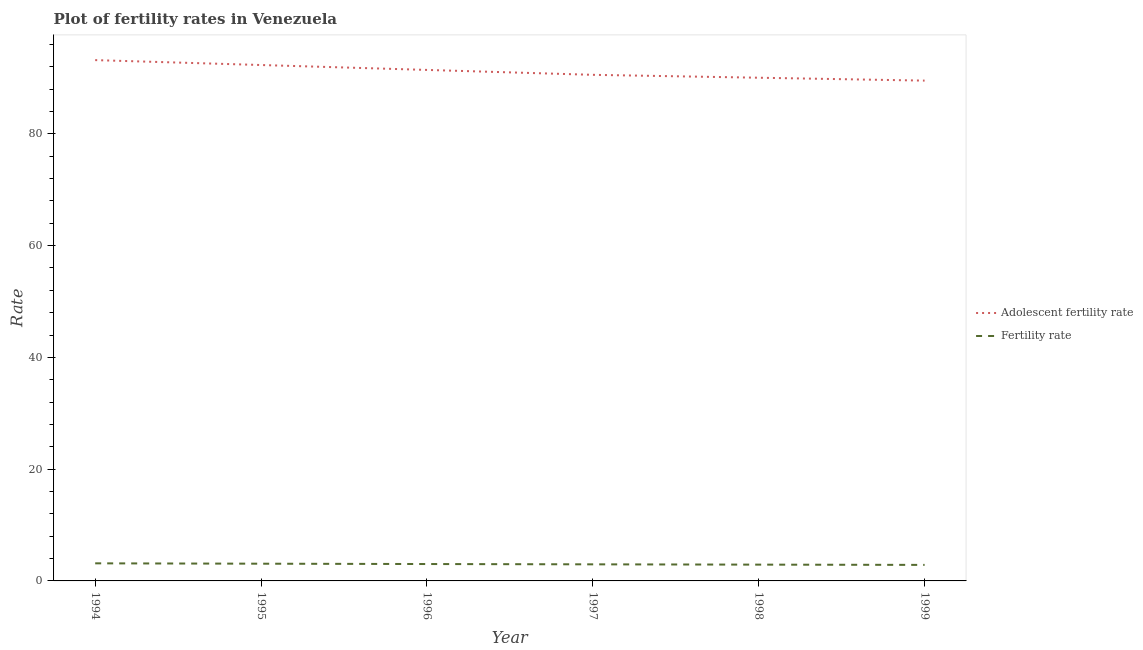How many different coloured lines are there?
Make the answer very short. 2. Does the line corresponding to fertility rate intersect with the line corresponding to adolescent fertility rate?
Give a very brief answer. No. Is the number of lines equal to the number of legend labels?
Offer a terse response. Yes. What is the fertility rate in 1996?
Offer a terse response. 3.02. Across all years, what is the maximum adolescent fertility rate?
Your answer should be very brief. 93.18. Across all years, what is the minimum adolescent fertility rate?
Keep it short and to the point. 89.52. In which year was the adolescent fertility rate maximum?
Keep it short and to the point. 1994. In which year was the adolescent fertility rate minimum?
Ensure brevity in your answer.  1999. What is the total adolescent fertility rate in the graph?
Provide a succinct answer. 547.02. What is the difference between the fertility rate in 1998 and that in 1999?
Keep it short and to the point. 0.05. What is the difference between the adolescent fertility rate in 1998 and the fertility rate in 1996?
Your answer should be compact. 87.01. What is the average adolescent fertility rate per year?
Keep it short and to the point. 91.17. In the year 1998, what is the difference between the fertility rate and adolescent fertility rate?
Make the answer very short. -87.12. What is the ratio of the fertility rate in 1994 to that in 1998?
Give a very brief answer. 1.08. Is the difference between the adolescent fertility rate in 1997 and 1998 greater than the difference between the fertility rate in 1997 and 1998?
Ensure brevity in your answer.  Yes. What is the difference between the highest and the second highest fertility rate?
Make the answer very short. 0.06. What is the difference between the highest and the lowest adolescent fertility rate?
Keep it short and to the point. 3.67. In how many years, is the fertility rate greater than the average fertility rate taken over all years?
Give a very brief answer. 3. Is the sum of the adolescent fertility rate in 1996 and 1999 greater than the maximum fertility rate across all years?
Your answer should be very brief. Yes. Does the adolescent fertility rate monotonically increase over the years?
Give a very brief answer. No. Is the fertility rate strictly less than the adolescent fertility rate over the years?
Give a very brief answer. Yes. How many years are there in the graph?
Keep it short and to the point. 6. Are the values on the major ticks of Y-axis written in scientific E-notation?
Give a very brief answer. No. Does the graph contain any zero values?
Offer a terse response. No. Does the graph contain grids?
Provide a succinct answer. No. Where does the legend appear in the graph?
Offer a very short reply. Center right. How are the legend labels stacked?
Provide a succinct answer. Vertical. What is the title of the graph?
Ensure brevity in your answer.  Plot of fertility rates in Venezuela. What is the label or title of the Y-axis?
Provide a succinct answer. Rate. What is the Rate in Adolescent fertility rate in 1994?
Your response must be concise. 93.18. What is the Rate in Fertility rate in 1994?
Give a very brief answer. 3.15. What is the Rate of Adolescent fertility rate in 1995?
Provide a succinct answer. 92.31. What is the Rate in Fertility rate in 1995?
Provide a succinct answer. 3.08. What is the Rate in Adolescent fertility rate in 1996?
Your response must be concise. 91.43. What is the Rate of Fertility rate in 1996?
Make the answer very short. 3.02. What is the Rate in Adolescent fertility rate in 1997?
Give a very brief answer. 90.55. What is the Rate of Fertility rate in 1997?
Ensure brevity in your answer.  2.97. What is the Rate of Adolescent fertility rate in 1998?
Provide a succinct answer. 90.03. What is the Rate of Fertility rate in 1998?
Keep it short and to the point. 2.92. What is the Rate of Adolescent fertility rate in 1999?
Your answer should be compact. 89.52. What is the Rate in Fertility rate in 1999?
Keep it short and to the point. 2.87. Across all years, what is the maximum Rate of Adolescent fertility rate?
Your answer should be very brief. 93.18. Across all years, what is the maximum Rate in Fertility rate?
Your answer should be very brief. 3.15. Across all years, what is the minimum Rate in Adolescent fertility rate?
Keep it short and to the point. 89.52. Across all years, what is the minimum Rate of Fertility rate?
Ensure brevity in your answer.  2.87. What is the total Rate of Adolescent fertility rate in the graph?
Your response must be concise. 547.02. What is the difference between the Rate of Adolescent fertility rate in 1994 and that in 1995?
Keep it short and to the point. 0.88. What is the difference between the Rate of Fertility rate in 1994 and that in 1995?
Give a very brief answer. 0.07. What is the difference between the Rate of Adolescent fertility rate in 1994 and that in 1996?
Provide a short and direct response. 1.76. What is the difference between the Rate of Adolescent fertility rate in 1994 and that in 1997?
Your response must be concise. 2.63. What is the difference between the Rate of Fertility rate in 1994 and that in 1997?
Make the answer very short. 0.18. What is the difference between the Rate in Adolescent fertility rate in 1994 and that in 1998?
Provide a short and direct response. 3.15. What is the difference between the Rate in Fertility rate in 1994 and that in 1998?
Offer a terse response. 0.23. What is the difference between the Rate of Adolescent fertility rate in 1994 and that in 1999?
Provide a short and direct response. 3.67. What is the difference between the Rate in Fertility rate in 1994 and that in 1999?
Give a very brief answer. 0.28. What is the difference between the Rate of Adolescent fertility rate in 1995 and that in 1996?
Offer a terse response. 0.88. What is the difference between the Rate in Fertility rate in 1995 and that in 1996?
Make the answer very short. 0.06. What is the difference between the Rate of Adolescent fertility rate in 1995 and that in 1997?
Offer a very short reply. 1.76. What is the difference between the Rate of Fertility rate in 1995 and that in 1997?
Offer a very short reply. 0.12. What is the difference between the Rate of Adolescent fertility rate in 1995 and that in 1998?
Your answer should be compact. 2.27. What is the difference between the Rate in Fertility rate in 1995 and that in 1998?
Provide a succinct answer. 0.17. What is the difference between the Rate in Adolescent fertility rate in 1995 and that in 1999?
Provide a short and direct response. 2.79. What is the difference between the Rate of Fertility rate in 1995 and that in 1999?
Keep it short and to the point. 0.21. What is the difference between the Rate of Adolescent fertility rate in 1996 and that in 1997?
Keep it short and to the point. 0.88. What is the difference between the Rate in Fertility rate in 1996 and that in 1997?
Offer a terse response. 0.06. What is the difference between the Rate of Adolescent fertility rate in 1996 and that in 1998?
Keep it short and to the point. 1.4. What is the difference between the Rate in Fertility rate in 1996 and that in 1998?
Your answer should be compact. 0.11. What is the difference between the Rate of Adolescent fertility rate in 1996 and that in 1999?
Your answer should be compact. 1.91. What is the difference between the Rate in Fertility rate in 1996 and that in 1999?
Offer a terse response. 0.15. What is the difference between the Rate of Adolescent fertility rate in 1997 and that in 1998?
Offer a very short reply. 0.52. What is the difference between the Rate of Fertility rate in 1997 and that in 1998?
Give a very brief answer. 0.05. What is the difference between the Rate in Adolescent fertility rate in 1997 and that in 1999?
Offer a terse response. 1.04. What is the difference between the Rate of Fertility rate in 1997 and that in 1999?
Your response must be concise. 0.1. What is the difference between the Rate in Adolescent fertility rate in 1998 and that in 1999?
Your answer should be compact. 0.52. What is the difference between the Rate of Fertility rate in 1998 and that in 1999?
Your answer should be very brief. 0.05. What is the difference between the Rate of Adolescent fertility rate in 1994 and the Rate of Fertility rate in 1995?
Keep it short and to the point. 90.1. What is the difference between the Rate in Adolescent fertility rate in 1994 and the Rate in Fertility rate in 1996?
Provide a succinct answer. 90.16. What is the difference between the Rate in Adolescent fertility rate in 1994 and the Rate in Fertility rate in 1997?
Offer a very short reply. 90.22. What is the difference between the Rate of Adolescent fertility rate in 1994 and the Rate of Fertility rate in 1998?
Your response must be concise. 90.27. What is the difference between the Rate of Adolescent fertility rate in 1994 and the Rate of Fertility rate in 1999?
Make the answer very short. 90.32. What is the difference between the Rate of Adolescent fertility rate in 1995 and the Rate of Fertility rate in 1996?
Your answer should be very brief. 89.28. What is the difference between the Rate in Adolescent fertility rate in 1995 and the Rate in Fertility rate in 1997?
Keep it short and to the point. 89.34. What is the difference between the Rate in Adolescent fertility rate in 1995 and the Rate in Fertility rate in 1998?
Keep it short and to the point. 89.39. What is the difference between the Rate in Adolescent fertility rate in 1995 and the Rate in Fertility rate in 1999?
Ensure brevity in your answer.  89.44. What is the difference between the Rate of Adolescent fertility rate in 1996 and the Rate of Fertility rate in 1997?
Keep it short and to the point. 88.46. What is the difference between the Rate in Adolescent fertility rate in 1996 and the Rate in Fertility rate in 1998?
Make the answer very short. 88.51. What is the difference between the Rate of Adolescent fertility rate in 1996 and the Rate of Fertility rate in 1999?
Your answer should be very brief. 88.56. What is the difference between the Rate in Adolescent fertility rate in 1997 and the Rate in Fertility rate in 1998?
Give a very brief answer. 87.64. What is the difference between the Rate in Adolescent fertility rate in 1997 and the Rate in Fertility rate in 1999?
Offer a terse response. 87.68. What is the difference between the Rate in Adolescent fertility rate in 1998 and the Rate in Fertility rate in 1999?
Provide a short and direct response. 87.17. What is the average Rate in Adolescent fertility rate per year?
Provide a short and direct response. 91.17. What is the average Rate in Fertility rate per year?
Ensure brevity in your answer.  3. In the year 1994, what is the difference between the Rate of Adolescent fertility rate and Rate of Fertility rate?
Your answer should be compact. 90.04. In the year 1995, what is the difference between the Rate of Adolescent fertility rate and Rate of Fertility rate?
Give a very brief answer. 89.22. In the year 1996, what is the difference between the Rate in Adolescent fertility rate and Rate in Fertility rate?
Your answer should be very brief. 88.41. In the year 1997, what is the difference between the Rate in Adolescent fertility rate and Rate in Fertility rate?
Provide a succinct answer. 87.58. In the year 1998, what is the difference between the Rate of Adolescent fertility rate and Rate of Fertility rate?
Your response must be concise. 87.12. In the year 1999, what is the difference between the Rate in Adolescent fertility rate and Rate in Fertility rate?
Your response must be concise. 86.65. What is the ratio of the Rate in Adolescent fertility rate in 1994 to that in 1995?
Ensure brevity in your answer.  1.01. What is the ratio of the Rate in Fertility rate in 1994 to that in 1995?
Your answer should be very brief. 1.02. What is the ratio of the Rate of Adolescent fertility rate in 1994 to that in 1996?
Your answer should be compact. 1.02. What is the ratio of the Rate in Fertility rate in 1994 to that in 1996?
Ensure brevity in your answer.  1.04. What is the ratio of the Rate in Adolescent fertility rate in 1994 to that in 1997?
Offer a very short reply. 1.03. What is the ratio of the Rate in Fertility rate in 1994 to that in 1997?
Your response must be concise. 1.06. What is the ratio of the Rate of Adolescent fertility rate in 1994 to that in 1998?
Ensure brevity in your answer.  1.03. What is the ratio of the Rate of Fertility rate in 1994 to that in 1998?
Provide a short and direct response. 1.08. What is the ratio of the Rate of Adolescent fertility rate in 1994 to that in 1999?
Offer a terse response. 1.04. What is the ratio of the Rate of Fertility rate in 1994 to that in 1999?
Provide a short and direct response. 1.1. What is the ratio of the Rate of Adolescent fertility rate in 1995 to that in 1996?
Your response must be concise. 1.01. What is the ratio of the Rate of Fertility rate in 1995 to that in 1996?
Your response must be concise. 1.02. What is the ratio of the Rate in Adolescent fertility rate in 1995 to that in 1997?
Give a very brief answer. 1.02. What is the ratio of the Rate of Fertility rate in 1995 to that in 1997?
Provide a short and direct response. 1.04. What is the ratio of the Rate of Adolescent fertility rate in 1995 to that in 1998?
Provide a succinct answer. 1.03. What is the ratio of the Rate of Fertility rate in 1995 to that in 1998?
Your answer should be very brief. 1.06. What is the ratio of the Rate in Adolescent fertility rate in 1995 to that in 1999?
Provide a succinct answer. 1.03. What is the ratio of the Rate in Fertility rate in 1995 to that in 1999?
Offer a very short reply. 1.07. What is the ratio of the Rate in Adolescent fertility rate in 1996 to that in 1997?
Offer a very short reply. 1.01. What is the ratio of the Rate in Fertility rate in 1996 to that in 1997?
Offer a very short reply. 1.02. What is the ratio of the Rate in Adolescent fertility rate in 1996 to that in 1998?
Give a very brief answer. 1.02. What is the ratio of the Rate in Fertility rate in 1996 to that in 1998?
Provide a short and direct response. 1.04. What is the ratio of the Rate of Adolescent fertility rate in 1996 to that in 1999?
Your answer should be very brief. 1.02. What is the ratio of the Rate of Fertility rate in 1996 to that in 1999?
Your answer should be very brief. 1.05. What is the ratio of the Rate in Adolescent fertility rate in 1997 to that in 1998?
Keep it short and to the point. 1.01. What is the ratio of the Rate of Fertility rate in 1997 to that in 1998?
Offer a terse response. 1.02. What is the ratio of the Rate of Adolescent fertility rate in 1997 to that in 1999?
Your answer should be compact. 1.01. What is the ratio of the Rate of Fertility rate in 1997 to that in 1999?
Your response must be concise. 1.03. What is the ratio of the Rate of Adolescent fertility rate in 1998 to that in 1999?
Your response must be concise. 1.01. What is the ratio of the Rate in Fertility rate in 1998 to that in 1999?
Give a very brief answer. 1.02. What is the difference between the highest and the second highest Rate in Adolescent fertility rate?
Provide a short and direct response. 0.88. What is the difference between the highest and the second highest Rate in Fertility rate?
Provide a succinct answer. 0.07. What is the difference between the highest and the lowest Rate in Adolescent fertility rate?
Your response must be concise. 3.67. What is the difference between the highest and the lowest Rate in Fertility rate?
Ensure brevity in your answer.  0.28. 